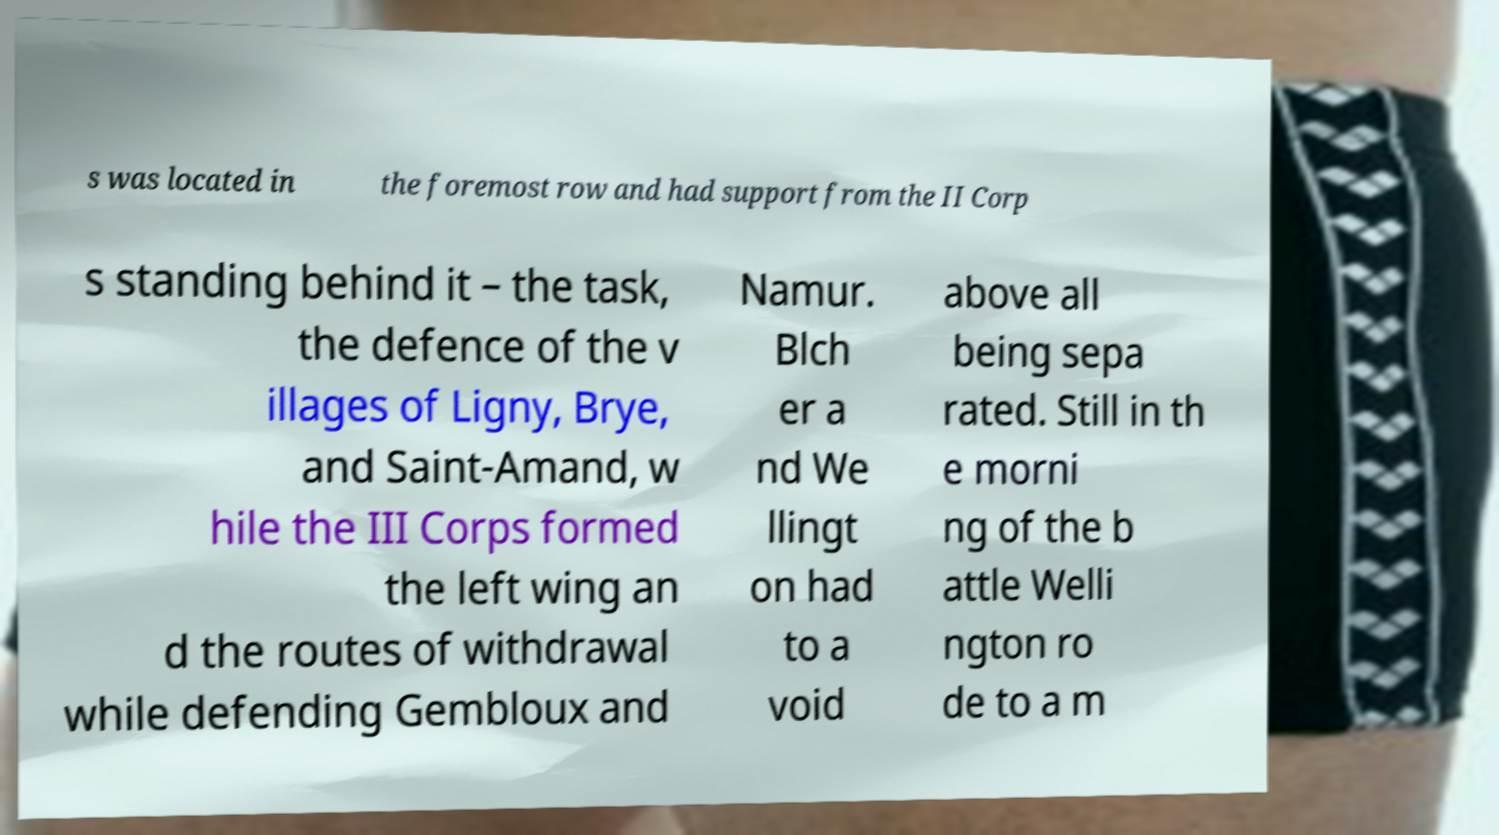What messages or text are displayed in this image? I need them in a readable, typed format. s was located in the foremost row and had support from the II Corp s standing behind it – the task, the defence of the v illages of Ligny, Brye, and Saint-Amand, w hile the III Corps formed the left wing an d the routes of withdrawal while defending Gembloux and Namur. Blch er a nd We llingt on had to a void above all being sepa rated. Still in th e morni ng of the b attle Welli ngton ro de to a m 